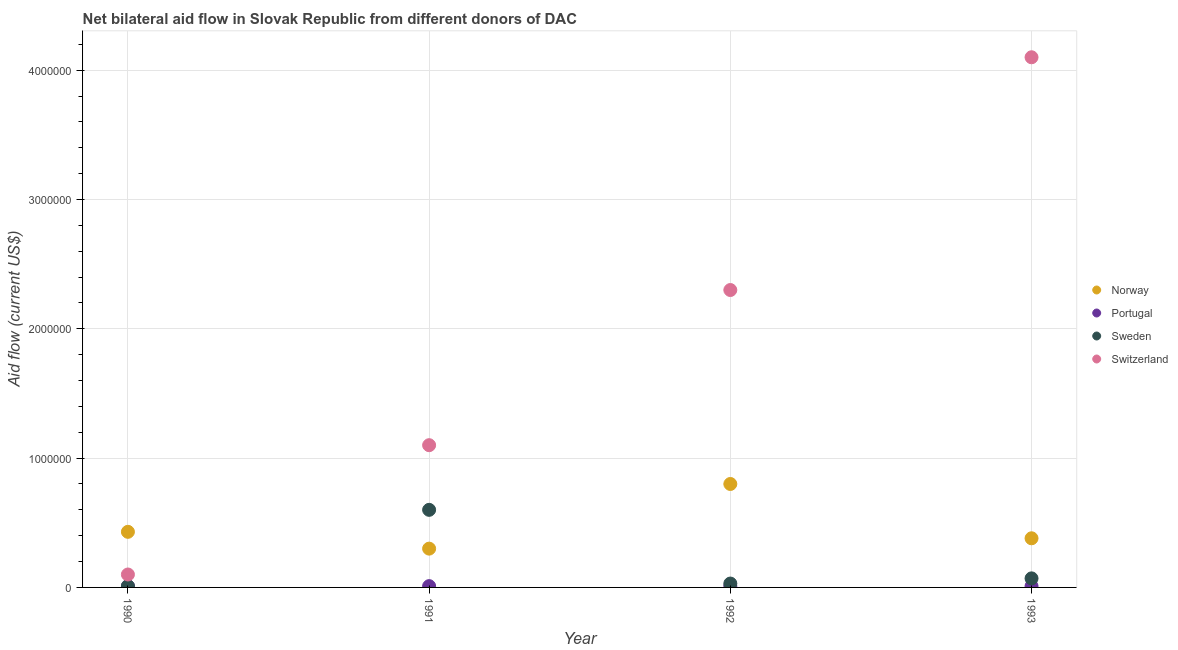Is the number of dotlines equal to the number of legend labels?
Ensure brevity in your answer.  Yes. What is the amount of aid given by portugal in 1990?
Your answer should be very brief. 10000. Across all years, what is the maximum amount of aid given by portugal?
Offer a very short reply. 10000. Across all years, what is the minimum amount of aid given by switzerland?
Provide a short and direct response. 1.00e+05. In which year was the amount of aid given by norway minimum?
Your answer should be compact. 1991. What is the total amount of aid given by norway in the graph?
Offer a very short reply. 1.91e+06. What is the difference between the amount of aid given by portugal in 1990 and the amount of aid given by switzerland in 1991?
Give a very brief answer. -1.09e+06. What is the average amount of aid given by norway per year?
Your answer should be compact. 4.78e+05. In the year 1993, what is the difference between the amount of aid given by portugal and amount of aid given by norway?
Provide a short and direct response. -3.70e+05. In how many years, is the amount of aid given by switzerland greater than 3200000 US$?
Your answer should be compact. 1. What is the ratio of the amount of aid given by portugal in 1990 to that in 1993?
Offer a terse response. 1. Is the amount of aid given by portugal in 1992 less than that in 1993?
Offer a very short reply. No. Is the difference between the amount of aid given by switzerland in 1991 and 1993 greater than the difference between the amount of aid given by sweden in 1991 and 1993?
Make the answer very short. No. What is the difference between the highest and the second highest amount of aid given by portugal?
Your answer should be compact. 0. What is the difference between the highest and the lowest amount of aid given by norway?
Ensure brevity in your answer.  5.00e+05. Is the sum of the amount of aid given by switzerland in 1990 and 1991 greater than the maximum amount of aid given by portugal across all years?
Make the answer very short. Yes. Does the amount of aid given by sweden monotonically increase over the years?
Ensure brevity in your answer.  No. Is the amount of aid given by switzerland strictly greater than the amount of aid given by sweden over the years?
Ensure brevity in your answer.  Yes. Is the amount of aid given by portugal strictly less than the amount of aid given by sweden over the years?
Ensure brevity in your answer.  No. How many years are there in the graph?
Ensure brevity in your answer.  4. What is the difference between two consecutive major ticks on the Y-axis?
Make the answer very short. 1.00e+06. Are the values on the major ticks of Y-axis written in scientific E-notation?
Provide a succinct answer. No. Does the graph contain any zero values?
Offer a terse response. No. Where does the legend appear in the graph?
Give a very brief answer. Center right. How are the legend labels stacked?
Keep it short and to the point. Vertical. What is the title of the graph?
Give a very brief answer. Net bilateral aid flow in Slovak Republic from different donors of DAC. What is the label or title of the Y-axis?
Provide a short and direct response. Aid flow (current US$). What is the Aid flow (current US$) of Portugal in 1990?
Offer a terse response. 10000. What is the Aid flow (current US$) in Sweden in 1990?
Provide a succinct answer. 10000. What is the Aid flow (current US$) in Switzerland in 1990?
Your answer should be compact. 1.00e+05. What is the Aid flow (current US$) in Portugal in 1991?
Your response must be concise. 10000. What is the Aid flow (current US$) of Sweden in 1991?
Give a very brief answer. 6.00e+05. What is the Aid flow (current US$) in Switzerland in 1991?
Ensure brevity in your answer.  1.10e+06. What is the Aid flow (current US$) of Sweden in 1992?
Keep it short and to the point. 3.00e+04. What is the Aid flow (current US$) of Switzerland in 1992?
Your response must be concise. 2.30e+06. What is the Aid flow (current US$) of Norway in 1993?
Make the answer very short. 3.80e+05. What is the Aid flow (current US$) of Portugal in 1993?
Your answer should be compact. 10000. What is the Aid flow (current US$) of Switzerland in 1993?
Offer a terse response. 4.10e+06. Across all years, what is the maximum Aid flow (current US$) in Portugal?
Give a very brief answer. 10000. Across all years, what is the maximum Aid flow (current US$) in Switzerland?
Keep it short and to the point. 4.10e+06. Across all years, what is the minimum Aid flow (current US$) in Norway?
Make the answer very short. 3.00e+05. Across all years, what is the minimum Aid flow (current US$) in Switzerland?
Keep it short and to the point. 1.00e+05. What is the total Aid flow (current US$) of Norway in the graph?
Provide a succinct answer. 1.91e+06. What is the total Aid flow (current US$) in Portugal in the graph?
Offer a very short reply. 4.00e+04. What is the total Aid flow (current US$) in Sweden in the graph?
Provide a succinct answer. 7.10e+05. What is the total Aid flow (current US$) of Switzerland in the graph?
Your answer should be very brief. 7.60e+06. What is the difference between the Aid flow (current US$) in Norway in 1990 and that in 1991?
Provide a short and direct response. 1.30e+05. What is the difference between the Aid flow (current US$) of Sweden in 1990 and that in 1991?
Give a very brief answer. -5.90e+05. What is the difference between the Aid flow (current US$) of Switzerland in 1990 and that in 1991?
Your answer should be very brief. -1.00e+06. What is the difference between the Aid flow (current US$) in Norway in 1990 and that in 1992?
Provide a succinct answer. -3.70e+05. What is the difference between the Aid flow (current US$) of Portugal in 1990 and that in 1992?
Give a very brief answer. 0. What is the difference between the Aid flow (current US$) of Switzerland in 1990 and that in 1992?
Provide a short and direct response. -2.20e+06. What is the difference between the Aid flow (current US$) in Portugal in 1990 and that in 1993?
Give a very brief answer. 0. What is the difference between the Aid flow (current US$) in Switzerland in 1990 and that in 1993?
Provide a short and direct response. -4.00e+06. What is the difference between the Aid flow (current US$) in Norway in 1991 and that in 1992?
Provide a short and direct response. -5.00e+05. What is the difference between the Aid flow (current US$) of Portugal in 1991 and that in 1992?
Give a very brief answer. 0. What is the difference between the Aid flow (current US$) in Sweden in 1991 and that in 1992?
Your response must be concise. 5.70e+05. What is the difference between the Aid flow (current US$) of Switzerland in 1991 and that in 1992?
Your answer should be compact. -1.20e+06. What is the difference between the Aid flow (current US$) of Norway in 1991 and that in 1993?
Provide a short and direct response. -8.00e+04. What is the difference between the Aid flow (current US$) in Sweden in 1991 and that in 1993?
Your answer should be compact. 5.30e+05. What is the difference between the Aid flow (current US$) in Norway in 1992 and that in 1993?
Your answer should be compact. 4.20e+05. What is the difference between the Aid flow (current US$) of Portugal in 1992 and that in 1993?
Your response must be concise. 0. What is the difference between the Aid flow (current US$) in Sweden in 1992 and that in 1993?
Your response must be concise. -4.00e+04. What is the difference between the Aid flow (current US$) of Switzerland in 1992 and that in 1993?
Give a very brief answer. -1.80e+06. What is the difference between the Aid flow (current US$) in Norway in 1990 and the Aid flow (current US$) in Switzerland in 1991?
Offer a terse response. -6.70e+05. What is the difference between the Aid flow (current US$) in Portugal in 1990 and the Aid flow (current US$) in Sweden in 1991?
Make the answer very short. -5.90e+05. What is the difference between the Aid flow (current US$) in Portugal in 1990 and the Aid flow (current US$) in Switzerland in 1991?
Offer a very short reply. -1.09e+06. What is the difference between the Aid flow (current US$) in Sweden in 1990 and the Aid flow (current US$) in Switzerland in 1991?
Offer a very short reply. -1.09e+06. What is the difference between the Aid flow (current US$) of Norway in 1990 and the Aid flow (current US$) of Sweden in 1992?
Your answer should be very brief. 4.00e+05. What is the difference between the Aid flow (current US$) of Norway in 1990 and the Aid flow (current US$) of Switzerland in 1992?
Provide a short and direct response. -1.87e+06. What is the difference between the Aid flow (current US$) of Portugal in 1990 and the Aid flow (current US$) of Switzerland in 1992?
Keep it short and to the point. -2.29e+06. What is the difference between the Aid flow (current US$) in Sweden in 1990 and the Aid flow (current US$) in Switzerland in 1992?
Give a very brief answer. -2.29e+06. What is the difference between the Aid flow (current US$) in Norway in 1990 and the Aid flow (current US$) in Portugal in 1993?
Your answer should be very brief. 4.20e+05. What is the difference between the Aid flow (current US$) in Norway in 1990 and the Aid flow (current US$) in Switzerland in 1993?
Provide a short and direct response. -3.67e+06. What is the difference between the Aid flow (current US$) in Portugal in 1990 and the Aid flow (current US$) in Switzerland in 1993?
Give a very brief answer. -4.09e+06. What is the difference between the Aid flow (current US$) in Sweden in 1990 and the Aid flow (current US$) in Switzerland in 1993?
Your answer should be very brief. -4.09e+06. What is the difference between the Aid flow (current US$) in Portugal in 1991 and the Aid flow (current US$) in Switzerland in 1992?
Your response must be concise. -2.29e+06. What is the difference between the Aid flow (current US$) in Sweden in 1991 and the Aid flow (current US$) in Switzerland in 1992?
Make the answer very short. -1.70e+06. What is the difference between the Aid flow (current US$) in Norway in 1991 and the Aid flow (current US$) in Sweden in 1993?
Provide a succinct answer. 2.30e+05. What is the difference between the Aid flow (current US$) of Norway in 1991 and the Aid flow (current US$) of Switzerland in 1993?
Provide a succinct answer. -3.80e+06. What is the difference between the Aid flow (current US$) of Portugal in 1991 and the Aid flow (current US$) of Switzerland in 1993?
Offer a very short reply. -4.09e+06. What is the difference between the Aid flow (current US$) of Sweden in 1991 and the Aid flow (current US$) of Switzerland in 1993?
Make the answer very short. -3.50e+06. What is the difference between the Aid flow (current US$) in Norway in 1992 and the Aid flow (current US$) in Portugal in 1993?
Your response must be concise. 7.90e+05. What is the difference between the Aid flow (current US$) in Norway in 1992 and the Aid flow (current US$) in Sweden in 1993?
Your response must be concise. 7.30e+05. What is the difference between the Aid flow (current US$) of Norway in 1992 and the Aid flow (current US$) of Switzerland in 1993?
Provide a succinct answer. -3.30e+06. What is the difference between the Aid flow (current US$) in Portugal in 1992 and the Aid flow (current US$) in Sweden in 1993?
Keep it short and to the point. -6.00e+04. What is the difference between the Aid flow (current US$) of Portugal in 1992 and the Aid flow (current US$) of Switzerland in 1993?
Your answer should be compact. -4.09e+06. What is the difference between the Aid flow (current US$) of Sweden in 1992 and the Aid flow (current US$) of Switzerland in 1993?
Make the answer very short. -4.07e+06. What is the average Aid flow (current US$) in Norway per year?
Give a very brief answer. 4.78e+05. What is the average Aid flow (current US$) of Sweden per year?
Offer a terse response. 1.78e+05. What is the average Aid flow (current US$) of Switzerland per year?
Provide a short and direct response. 1.90e+06. In the year 1990, what is the difference between the Aid flow (current US$) in Norway and Aid flow (current US$) in Switzerland?
Make the answer very short. 3.30e+05. In the year 1990, what is the difference between the Aid flow (current US$) of Portugal and Aid flow (current US$) of Sweden?
Your answer should be compact. 0. In the year 1991, what is the difference between the Aid flow (current US$) of Norway and Aid flow (current US$) of Portugal?
Provide a succinct answer. 2.90e+05. In the year 1991, what is the difference between the Aid flow (current US$) of Norway and Aid flow (current US$) of Switzerland?
Make the answer very short. -8.00e+05. In the year 1991, what is the difference between the Aid flow (current US$) of Portugal and Aid flow (current US$) of Sweden?
Keep it short and to the point. -5.90e+05. In the year 1991, what is the difference between the Aid flow (current US$) in Portugal and Aid flow (current US$) in Switzerland?
Provide a succinct answer. -1.09e+06. In the year 1991, what is the difference between the Aid flow (current US$) of Sweden and Aid flow (current US$) of Switzerland?
Your answer should be compact. -5.00e+05. In the year 1992, what is the difference between the Aid flow (current US$) of Norway and Aid flow (current US$) of Portugal?
Make the answer very short. 7.90e+05. In the year 1992, what is the difference between the Aid flow (current US$) in Norway and Aid flow (current US$) in Sweden?
Your answer should be very brief. 7.70e+05. In the year 1992, what is the difference between the Aid flow (current US$) in Norway and Aid flow (current US$) in Switzerland?
Give a very brief answer. -1.50e+06. In the year 1992, what is the difference between the Aid flow (current US$) of Portugal and Aid flow (current US$) of Switzerland?
Your answer should be compact. -2.29e+06. In the year 1992, what is the difference between the Aid flow (current US$) in Sweden and Aid flow (current US$) in Switzerland?
Provide a succinct answer. -2.27e+06. In the year 1993, what is the difference between the Aid flow (current US$) in Norway and Aid flow (current US$) in Portugal?
Offer a very short reply. 3.70e+05. In the year 1993, what is the difference between the Aid flow (current US$) of Norway and Aid flow (current US$) of Switzerland?
Give a very brief answer. -3.72e+06. In the year 1993, what is the difference between the Aid flow (current US$) of Portugal and Aid flow (current US$) of Switzerland?
Your response must be concise. -4.09e+06. In the year 1993, what is the difference between the Aid flow (current US$) of Sweden and Aid flow (current US$) of Switzerland?
Keep it short and to the point. -4.03e+06. What is the ratio of the Aid flow (current US$) of Norway in 1990 to that in 1991?
Keep it short and to the point. 1.43. What is the ratio of the Aid flow (current US$) of Sweden in 1990 to that in 1991?
Your answer should be very brief. 0.02. What is the ratio of the Aid flow (current US$) of Switzerland in 1990 to that in 1991?
Your response must be concise. 0.09. What is the ratio of the Aid flow (current US$) of Norway in 1990 to that in 1992?
Provide a succinct answer. 0.54. What is the ratio of the Aid flow (current US$) of Sweden in 1990 to that in 1992?
Provide a short and direct response. 0.33. What is the ratio of the Aid flow (current US$) of Switzerland in 1990 to that in 1992?
Provide a short and direct response. 0.04. What is the ratio of the Aid flow (current US$) in Norway in 1990 to that in 1993?
Provide a succinct answer. 1.13. What is the ratio of the Aid flow (current US$) of Portugal in 1990 to that in 1993?
Offer a very short reply. 1. What is the ratio of the Aid flow (current US$) in Sweden in 1990 to that in 1993?
Offer a very short reply. 0.14. What is the ratio of the Aid flow (current US$) in Switzerland in 1990 to that in 1993?
Offer a terse response. 0.02. What is the ratio of the Aid flow (current US$) of Norway in 1991 to that in 1992?
Ensure brevity in your answer.  0.38. What is the ratio of the Aid flow (current US$) in Portugal in 1991 to that in 1992?
Give a very brief answer. 1. What is the ratio of the Aid flow (current US$) in Sweden in 1991 to that in 1992?
Your response must be concise. 20. What is the ratio of the Aid flow (current US$) of Switzerland in 1991 to that in 1992?
Keep it short and to the point. 0.48. What is the ratio of the Aid flow (current US$) of Norway in 1991 to that in 1993?
Your response must be concise. 0.79. What is the ratio of the Aid flow (current US$) in Sweden in 1991 to that in 1993?
Your answer should be very brief. 8.57. What is the ratio of the Aid flow (current US$) in Switzerland in 1991 to that in 1993?
Offer a terse response. 0.27. What is the ratio of the Aid flow (current US$) of Norway in 1992 to that in 1993?
Offer a very short reply. 2.11. What is the ratio of the Aid flow (current US$) in Sweden in 1992 to that in 1993?
Offer a terse response. 0.43. What is the ratio of the Aid flow (current US$) of Switzerland in 1992 to that in 1993?
Make the answer very short. 0.56. What is the difference between the highest and the second highest Aid flow (current US$) of Portugal?
Offer a terse response. 0. What is the difference between the highest and the second highest Aid flow (current US$) in Sweden?
Offer a terse response. 5.30e+05. What is the difference between the highest and the second highest Aid flow (current US$) of Switzerland?
Give a very brief answer. 1.80e+06. What is the difference between the highest and the lowest Aid flow (current US$) of Sweden?
Provide a short and direct response. 5.90e+05. What is the difference between the highest and the lowest Aid flow (current US$) of Switzerland?
Your response must be concise. 4.00e+06. 